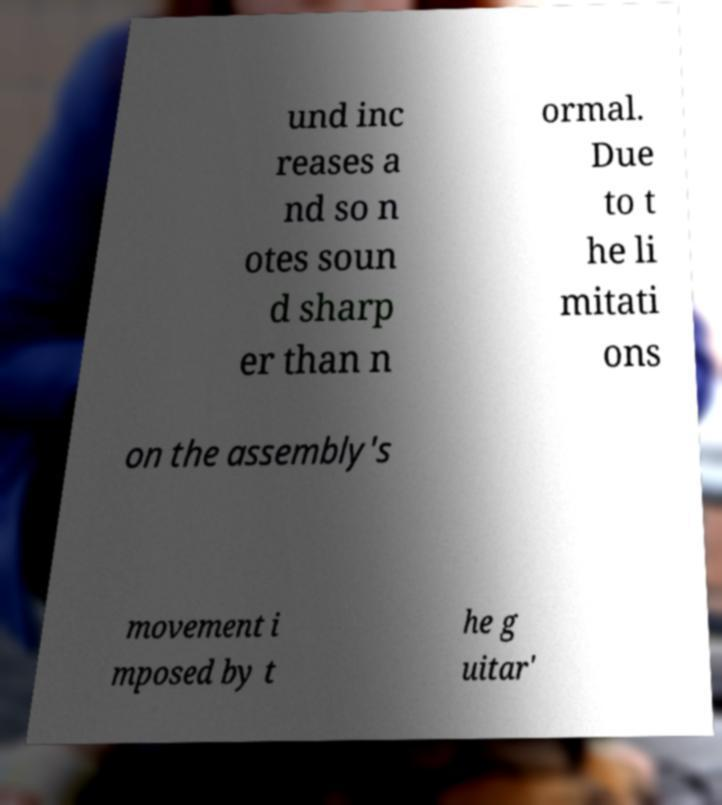There's text embedded in this image that I need extracted. Can you transcribe it verbatim? und inc reases a nd so n otes soun d sharp er than n ormal. Due to t he li mitati ons on the assembly's movement i mposed by t he g uitar' 